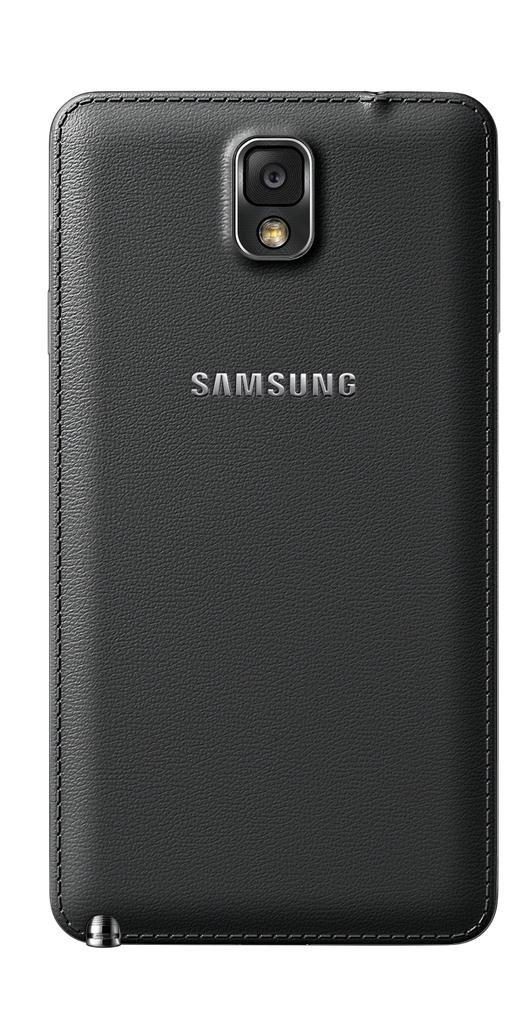<image>
Render a clear and concise summary of the photo. The black leather cell phone case is made for Samsung phones. 